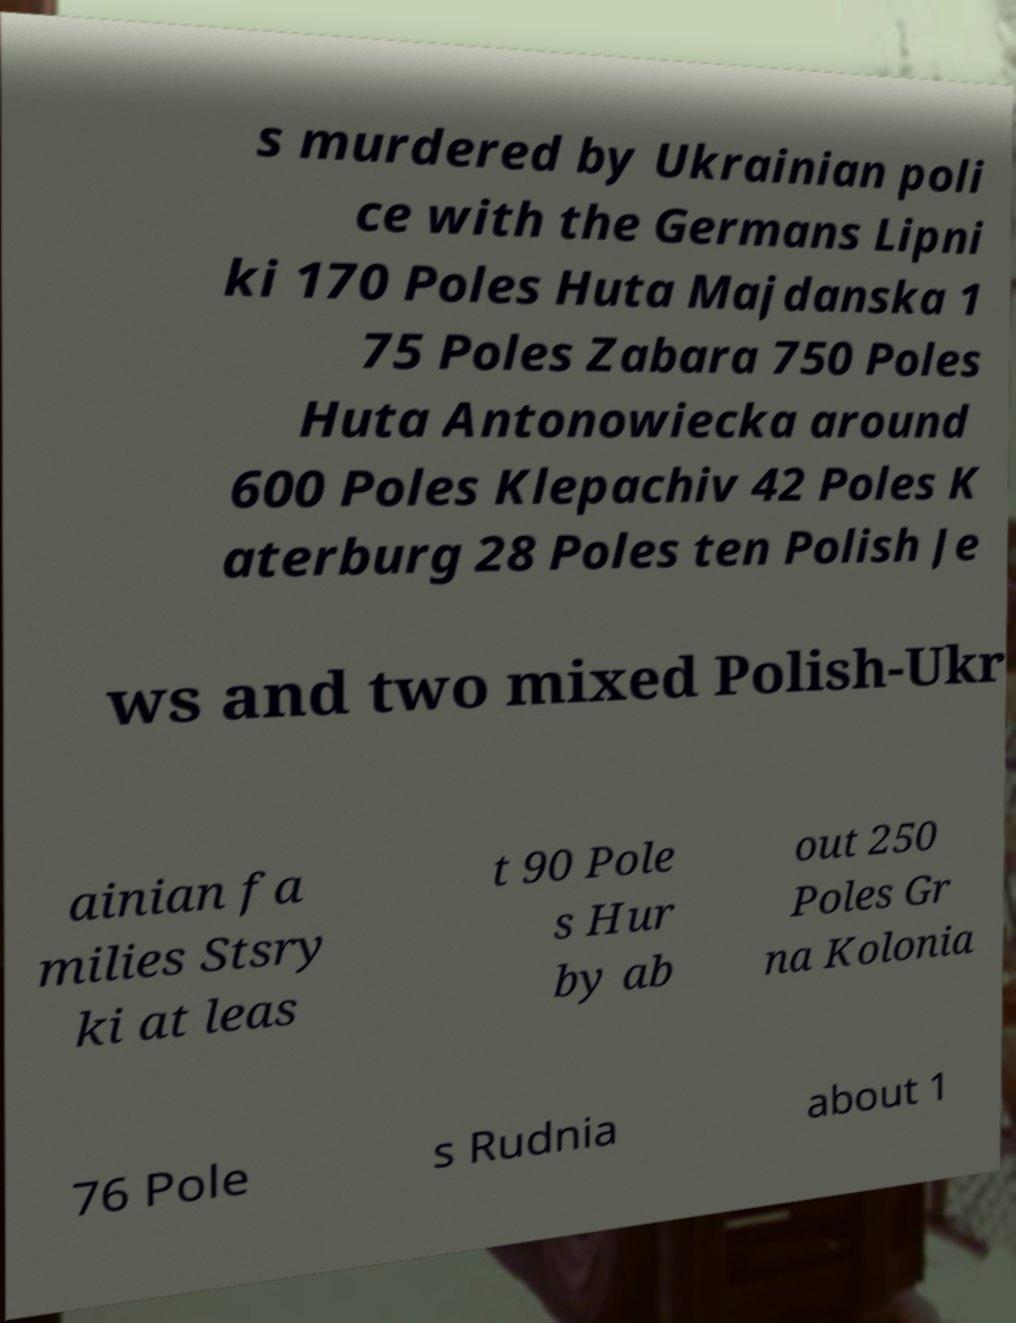For documentation purposes, I need the text within this image transcribed. Could you provide that? s murdered by Ukrainian poli ce with the Germans Lipni ki 170 Poles Huta Majdanska 1 75 Poles Zabara 750 Poles Huta Antonowiecka around 600 Poles Klepachiv 42 Poles K aterburg 28 Poles ten Polish Je ws and two mixed Polish-Ukr ainian fa milies Stsry ki at leas t 90 Pole s Hur by ab out 250 Poles Gr na Kolonia 76 Pole s Rudnia about 1 